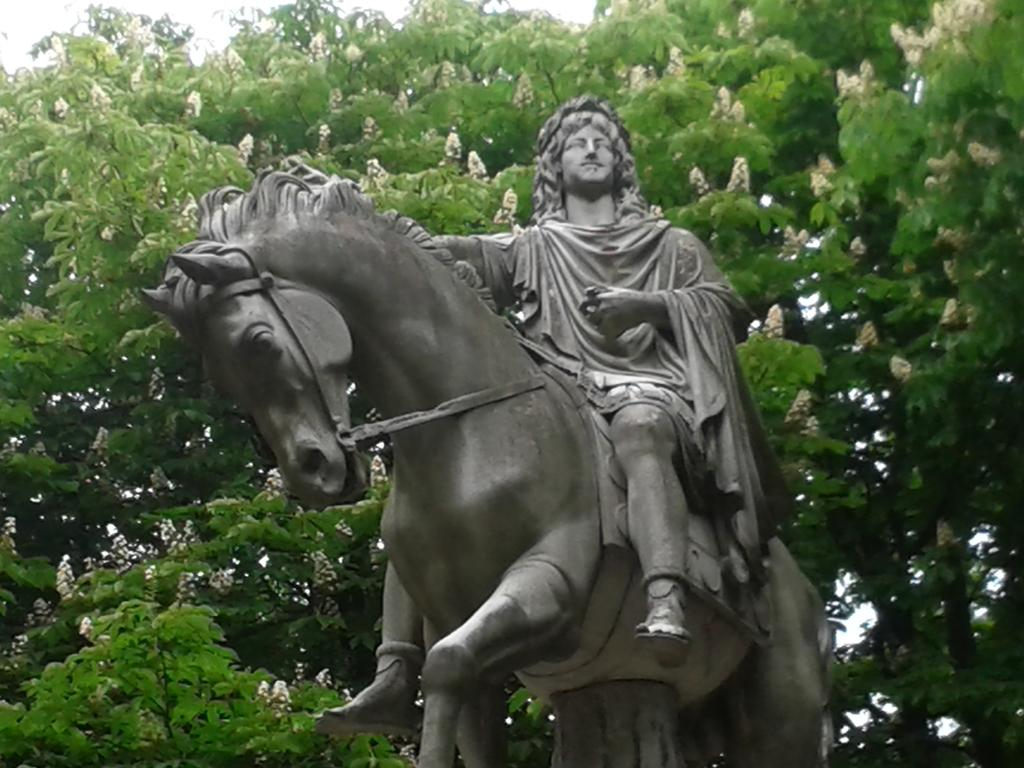What is the main subject of the image? There is a statue of a person sitting on a horse in the image. What is located behind the statue? There is a tree at the back of the statue. What can be seen on the tree? There are flowers on the tree. What is visible at the top of the image? The sky is visible at the top of the image. What song is being played by the statue in the image? There is no indication in the image that the statue is playing a song, as statues are not capable of playing music. 